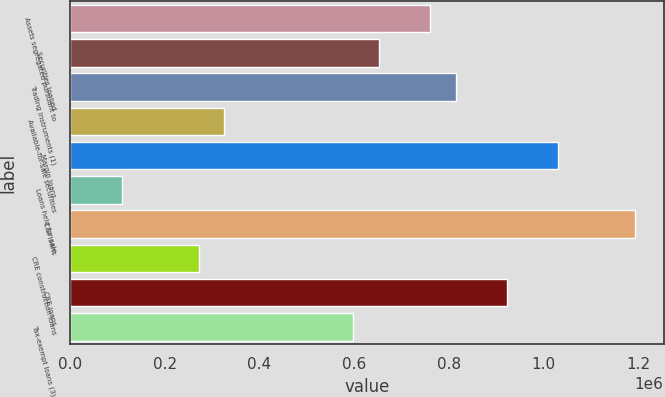Convert chart. <chart><loc_0><loc_0><loc_500><loc_500><bar_chart><fcel>Assets segregated pursuant to<fcel>Securities loaned<fcel>Trading instruments (1)<fcel>Available-for-sale securities<fcel>Margin loans<fcel>Loans held for sale<fcel>C&I loans<fcel>CRE construction loans<fcel>CRE loans<fcel>Tax-exempt loans (3)<nl><fcel>760219<fcel>651750<fcel>814453<fcel>326345<fcel>1.03139e+06<fcel>109408<fcel>1.19409e+06<fcel>272111<fcel>922921<fcel>597516<nl></chart> 